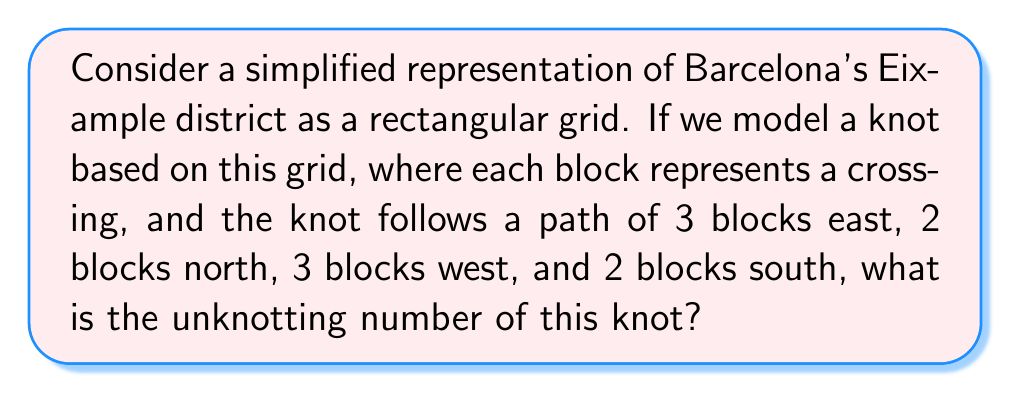Give your solution to this math problem. To solve this problem, let's follow these steps:

1. Visualize the knot:
   The knot follows a rectangular path on the grid:
   3 blocks east, 2 blocks north, 3 blocks west, 2 blocks south.

2. Count the crossings:
   In this simplified model, each block represents a crossing.
   Total crossings = 3 + 2 + 3 + 2 = 10

3. Analyze the knot type:
   This knot is actually a simple loop, equivalent to the unknot.

4. Define unknotting number:
   The unknotting number is the minimum number of crossing changes needed to transform a knot into the unknot.

5. Calculate the unknotting number:
   Since this knot is already equivalent to the unknot, no crossing changes are needed.

6. Express the result:
   The unknotting number is 0.

This simplified model demonstrates how urban planning concepts can be applied to mathematical knot theory, reflecting the organized grid system of Barcelona's Eixample district.
Answer: 0 